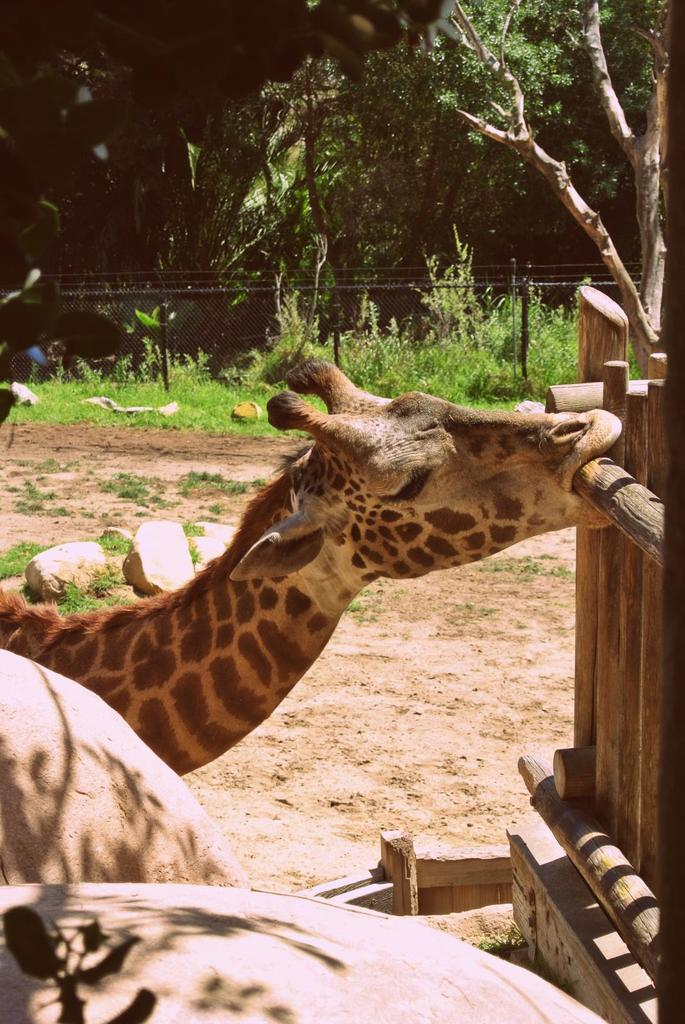What animal is present in the image? There is a giraffe in the image. What is the color of the giraffe? The giraffe is brown in color. What type of vegetation can be seen in the image? There are trees and grass in the image. What type of whip can be seen in the image? There is no whip present in the image. How many bubbles are floating around the giraffe in the image? There are no bubbles present in the image. 